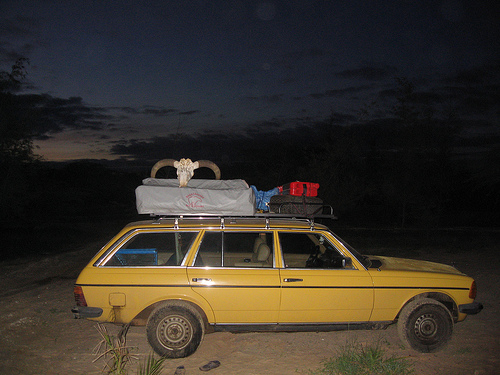<image>
Is there a suitcase above the car? Yes. The suitcase is positioned above the car in the vertical space, higher up in the scene. 